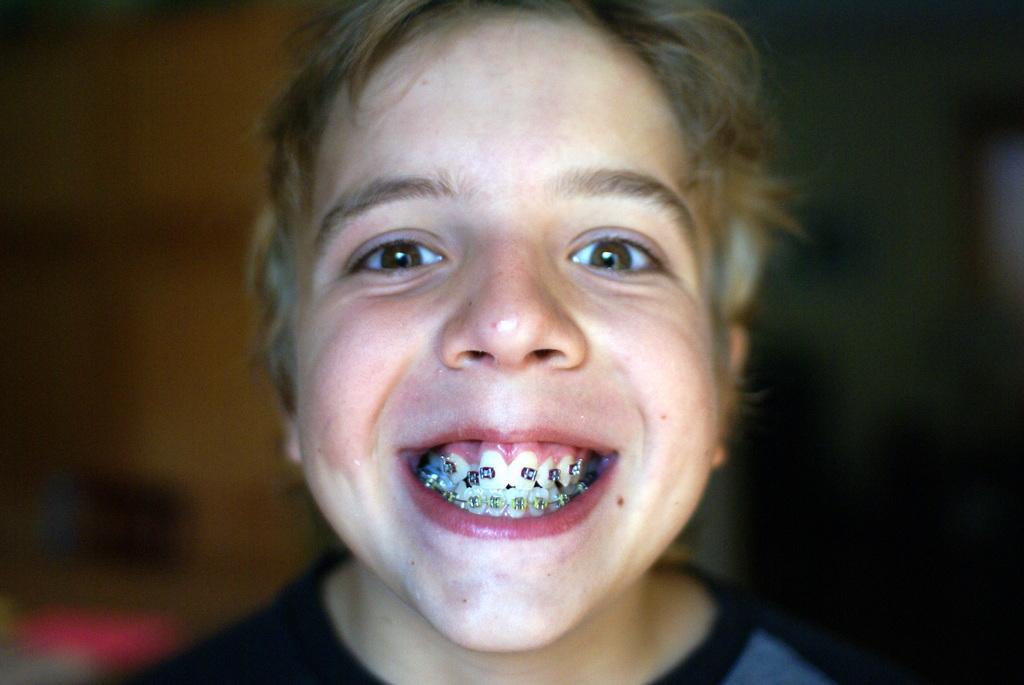Please provide a concise description of this image. In this picture we can see a kid smiling here, we can see a blurry background. 